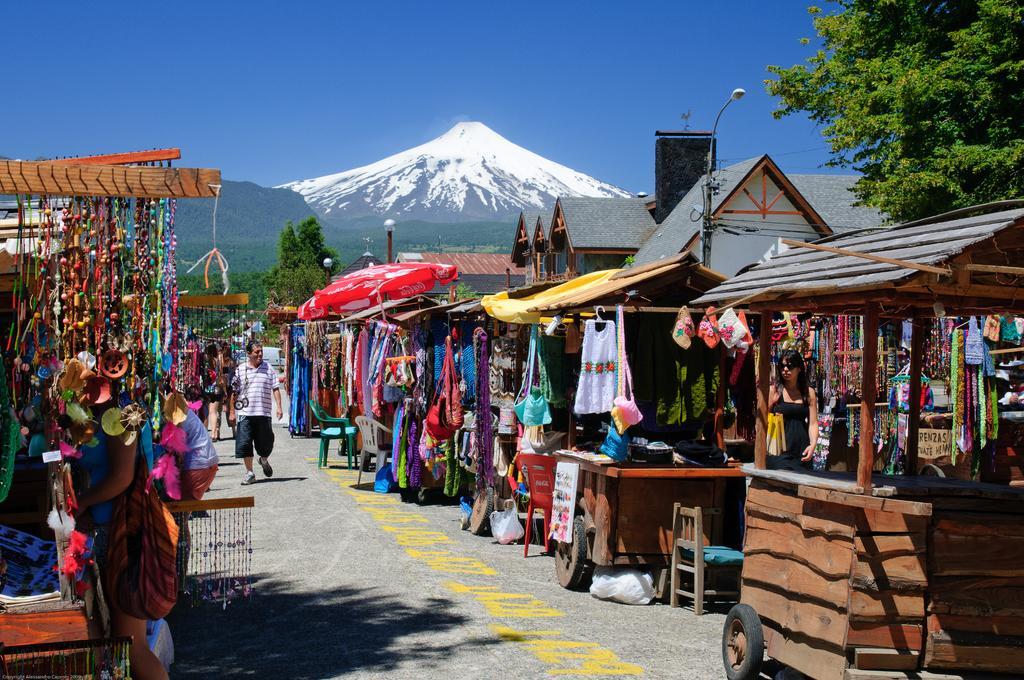Please provide a concise description of this image. In this image i can see different types of shops and at the background of the image there are trees,mountains and clear sky. 